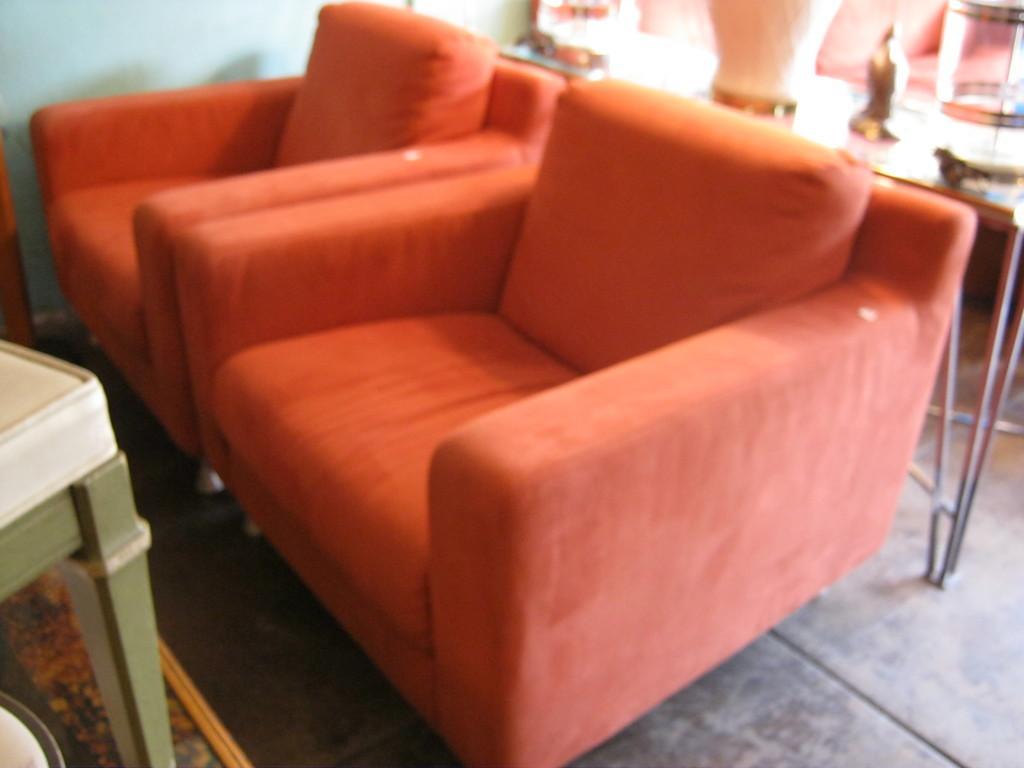Describe this image in one or two sentences. In this image we can see two sofa chairs. In the background we can see a table. 